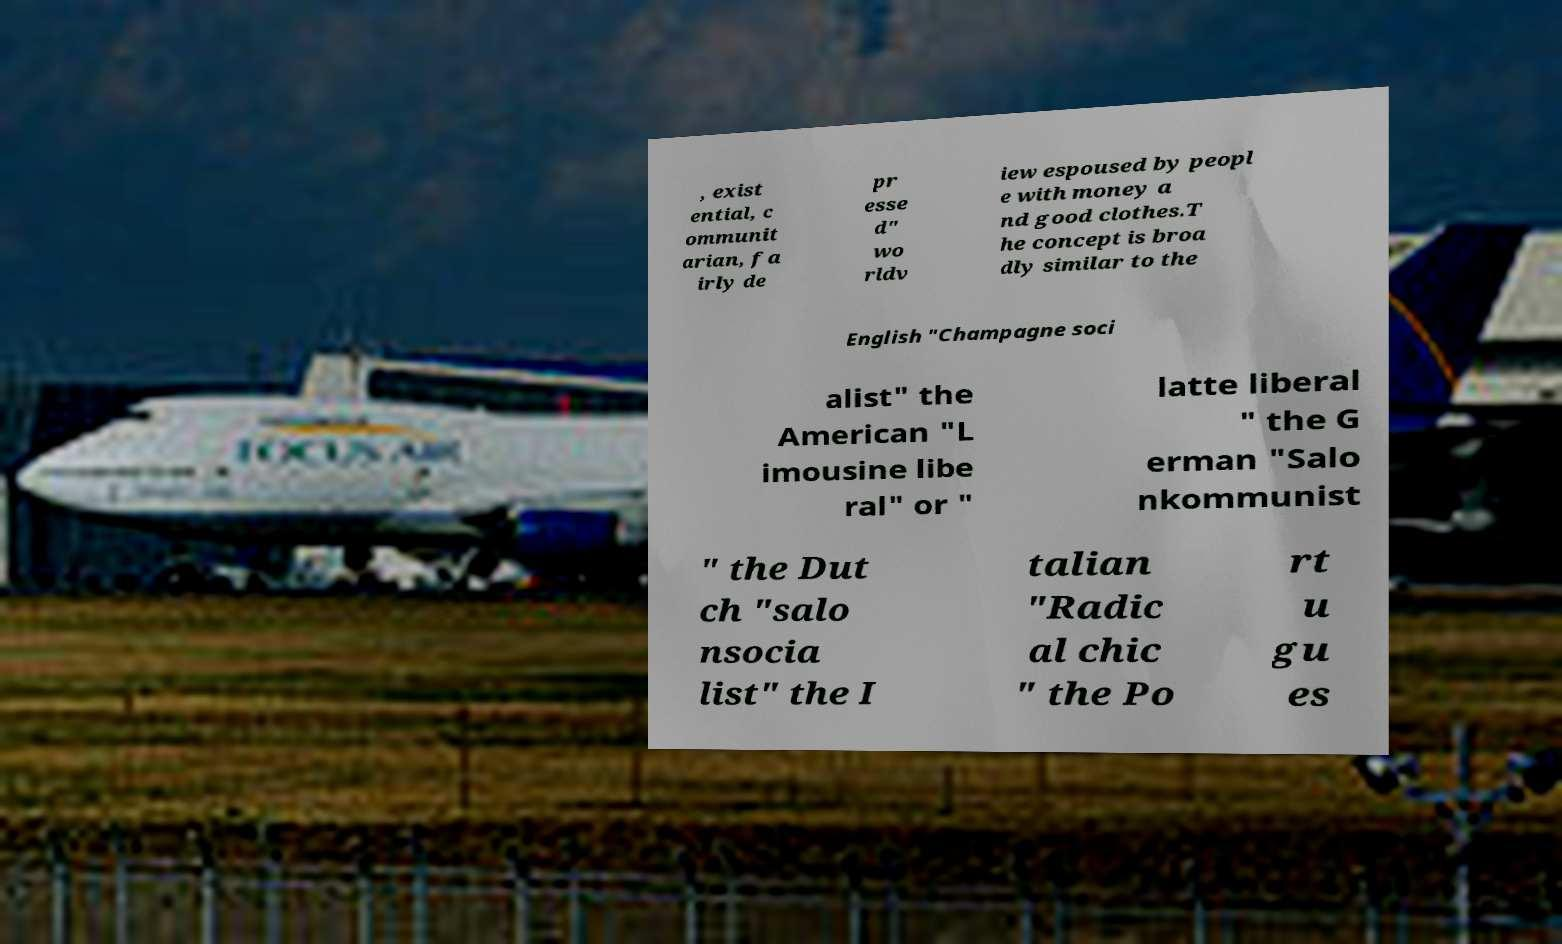Please identify and transcribe the text found in this image. , exist ential, c ommunit arian, fa irly de pr esse d" wo rldv iew espoused by peopl e with money a nd good clothes.T he concept is broa dly similar to the English "Champagne soci alist" the American "L imousine libe ral" or " latte liberal " the G erman "Salo nkommunist " the Dut ch "salo nsocia list" the I talian "Radic al chic " the Po rt u gu es 